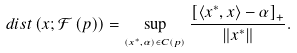<formula> <loc_0><loc_0><loc_500><loc_500>d i s t \left ( x ; \mathcal { F } \left ( p \right ) \right ) = \sup _ { _ { \left ( x ^ { \ast } , \alpha \right ) \in C \left ( p \right ) } } \frac { \left [ \left \langle x ^ { \ast } , x \right \rangle - \alpha \right ] _ { + } } { \left \| x ^ { \ast } \right \| } .</formula> 